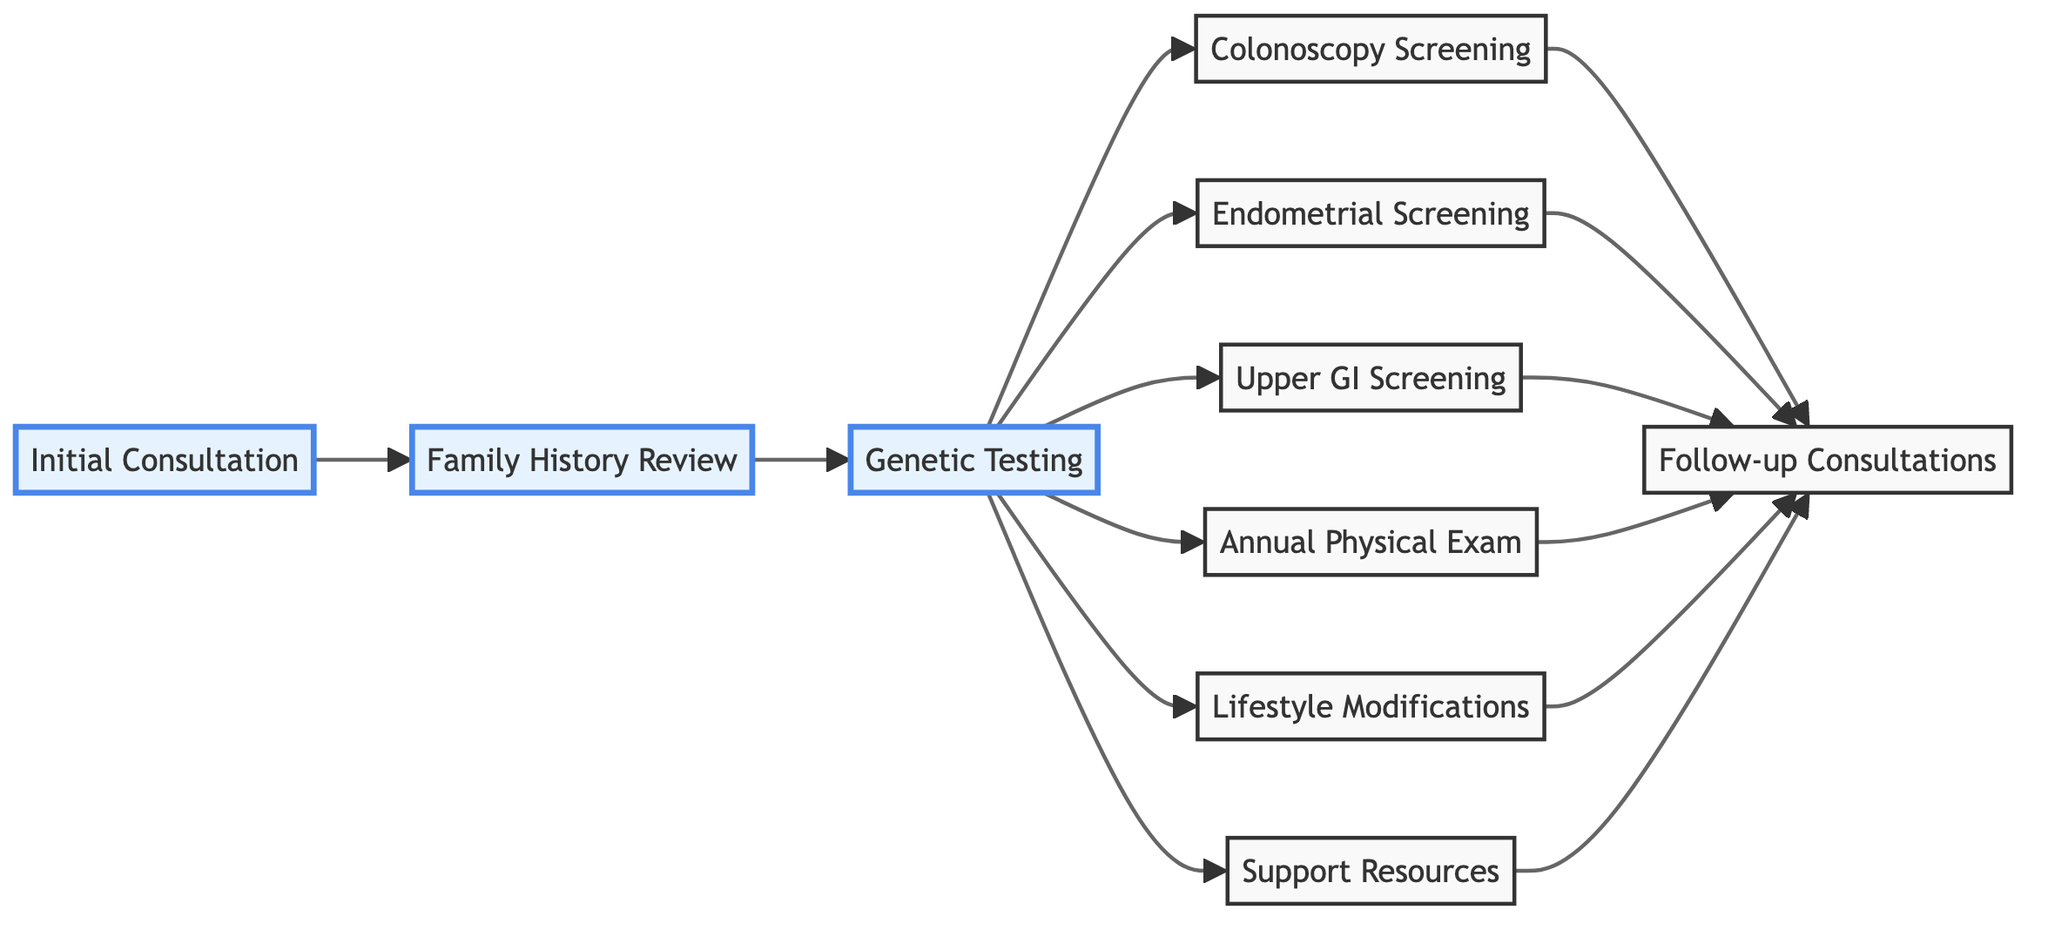What is the first step in the health management plan? The first step in the diagram is "Initial Consultation." It is the first node presented and sets the foundation for the subsequent actions in the health management plan.
Answer: Initial Consultation How many screenings are recommended after genetic testing? After the "Genetic Testing" node, three screenings are listed: "Colonoscopy Screening," "Endometrial Screening," and "Upper GI Screening." Therefore, the number of screenings is three.
Answer: 3 What are the starting ages for "Colonoscopy Screening"? The diagram states that routine colonoscopies should begin at age 20-25 or 2-5 years before the youngest case in the family. This provides a range for the starting ages for colonoscopy and contributes to the understanding of the timeline.
Answer: 20-25 Which step involves accessing emotional support? The "Support Resources" node specifically mentions accessing support groups and counseling services to manage emotional well-being. It directly addresses the aspect of emotional support within the health management plan.
Answer: Support Resources What is the last node connected to multiple screenings? The last node connected to the multiple screening nodes (Colonoscopy, Endometrial, Upper GI, Physical Exam, and Lifestyle Modifications) is "Follow-up Consultations." This node consolidates actions from previous nodes aimed at ongoing health management.
Answer: Follow-up Consultations For which age group is "Endometrial Screening" recommended? The diagram indicates that "Endometrial Screening" should start for women beginning at age 30-35. This specifies the target demographic for that particular screening action.
Answer: 30-35 What two nodes directly follow "Genetic Testing"? After "Genetic Testing," the diagram shows three nodes (Colonoscopy Screening, Endometrial Screening, and Upper GI Screening). However, if focusing on the first two following connections, the answer would be "Colonoscopy Screening" and "Endometrial Screening."
Answer: Colonoscopy Screening, Endometrial Screening What classifies "Lifestyle Modifications"? The "Lifestyle Modifications" node entails adopting a healthy lifestyle that includes a balanced diet, regular exercise, and avoiding smoking, thus it contributes to the overall health management strategy indicated in the diagram.
Answer: Lifestyle Modifications How are the physical examination results used in the health management plan? The "Annual Physical Examination" node signifies regular check-ups aimed at monitoring overall health. This suggests that the results would be used to make adjustments in the health management plan as necessary during follow-up consultations.
Answer: Annual Physical Examination 